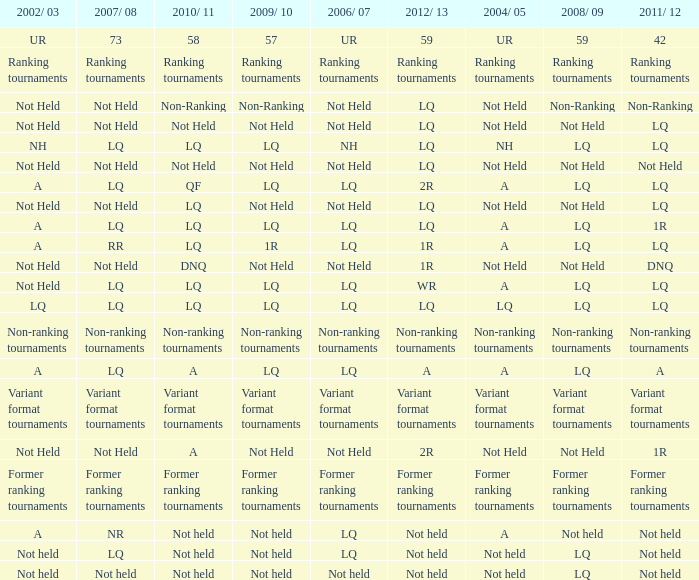Name the 2009/10 with 2011/12 of lq and 2008/09 of not held Not Held, Not Held. 